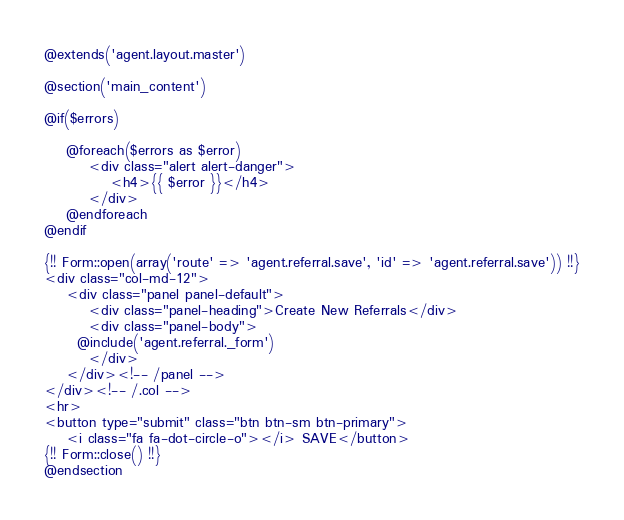<code> <loc_0><loc_0><loc_500><loc_500><_PHP_>@extends('agent.layout.master')

@section('main_content')

@if($errors)

	@foreach($errors as $error)
		<div class="alert alert-danger">
			<h4>{{ $error }}</h4>
		</div>
	@endforeach
@endif

{!! Form::open(array('route' => 'agent.referral.save', 'id' => 'agent.referral.save')) !!}
<div class="col-md-12">
	<div class="panel panel-default">
		<div class="panel-heading">Create New Referrals</div>
		<div class="panel-body">
      @include('agent.referral._form')
		</div>
	</div><!-- /panel -->
</div><!-- /.col -->
<hr>
<button type="submit" class="btn btn-sm btn-primary">
	<i class="fa fa-dot-circle-o"></i> SAVE</button>
{!! Form::close() !!}
@endsection
</code> 